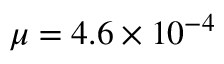<formula> <loc_0><loc_0><loc_500><loc_500>\mu = 4 . 6 \times 1 0 ^ { - 4 }</formula> 